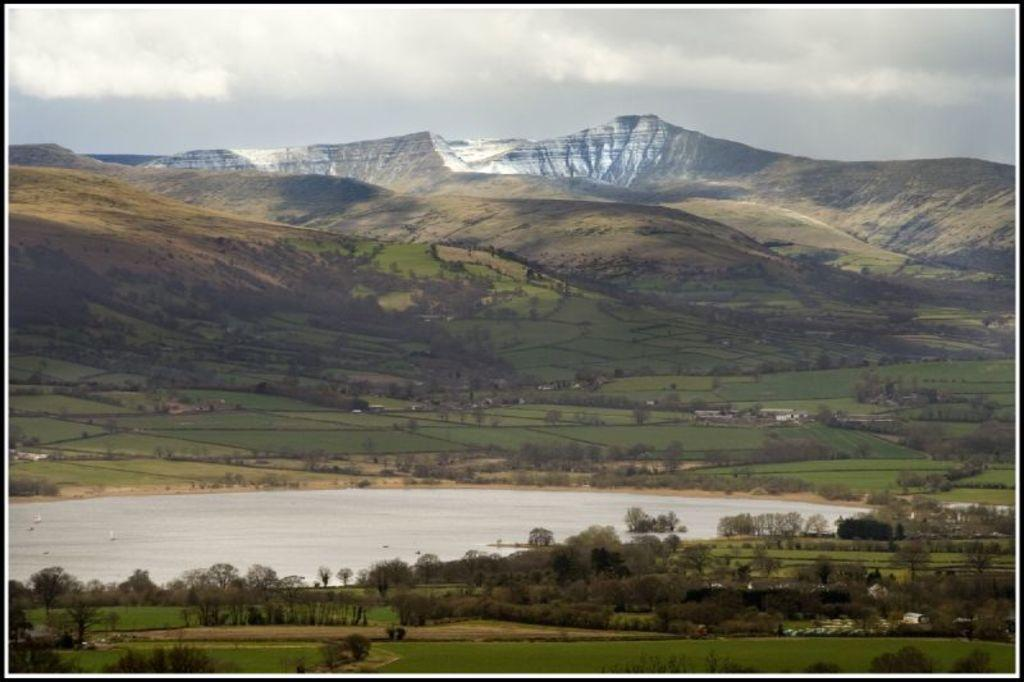What type of natural elements can be seen in the image? There are trees and mountains in the image. What is on the ground in the image? There is water on the ground in the image. What is visible in the background of the image? The sky is visible in the background of the image. What can be seen in the sky? There are clouds in the sky. What type of voice can be heard coming from the trees in the image? There is no voice present in the image, as trees do not have the ability to produce sound. How many pigs are visible in the image? There are no pigs present in the image. 